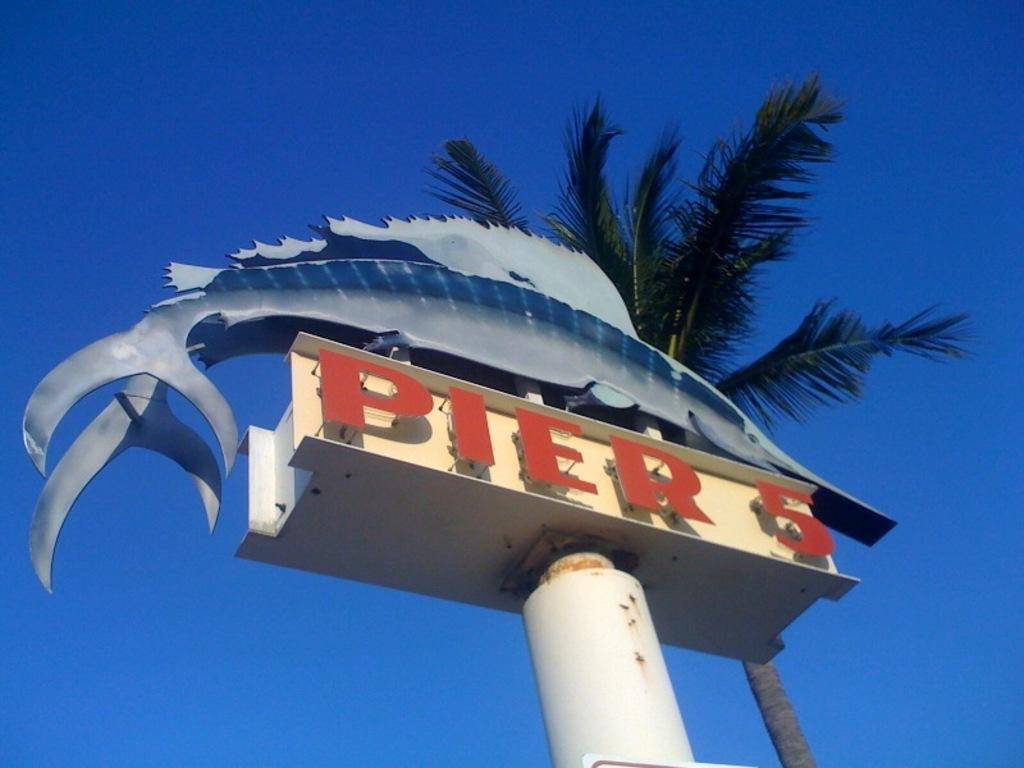What type of natural element is present in the image? There is a tree in the image. What man-made object can be seen in the image? There is a signboard in the image. Can you describe any other objects in the image? There are other objects in the image, but their specific details are not mentioned in the provided facts. What can be seen in the background of the image? The sky is visible in the background of the image. How many crates are stacked next to the tree in the image? There is no crate present in the image. Are the brothers standing near the signboard in the image? There is no mention of brothers in the provided facts, and therefore we cannot answer this question. 